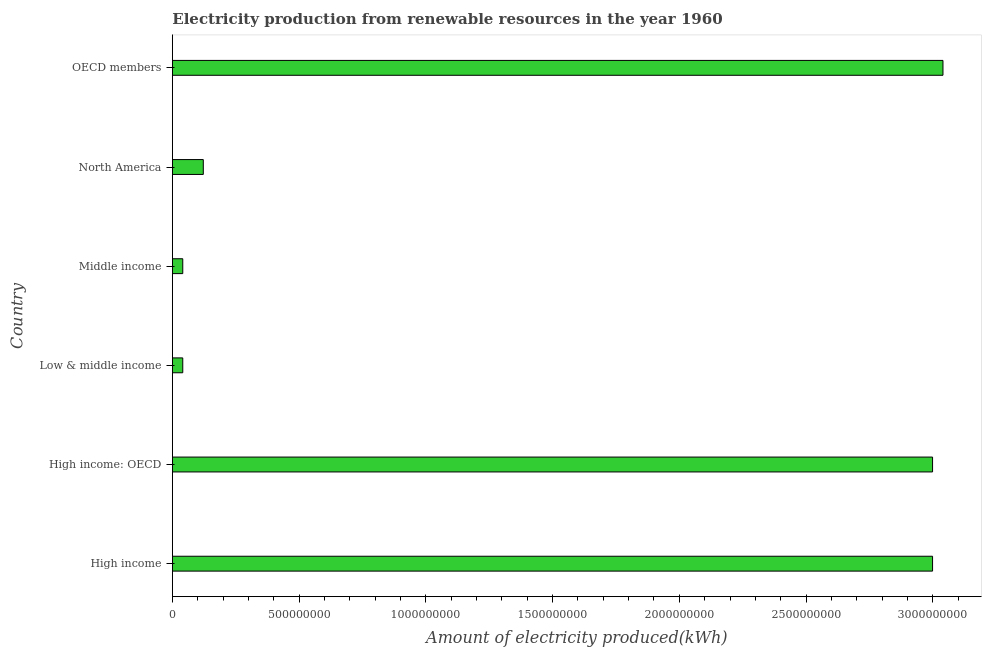What is the title of the graph?
Provide a short and direct response. Electricity production from renewable resources in the year 1960. What is the label or title of the X-axis?
Provide a short and direct response. Amount of electricity produced(kWh). What is the amount of electricity produced in Low & middle income?
Your answer should be compact. 4.10e+07. Across all countries, what is the maximum amount of electricity produced?
Ensure brevity in your answer.  3.04e+09. Across all countries, what is the minimum amount of electricity produced?
Ensure brevity in your answer.  4.10e+07. In which country was the amount of electricity produced minimum?
Provide a short and direct response. Low & middle income. What is the sum of the amount of electricity produced?
Provide a short and direct response. 9.24e+09. What is the difference between the amount of electricity produced in High income and Low & middle income?
Offer a very short reply. 2.96e+09. What is the average amount of electricity produced per country?
Your response must be concise. 1.54e+09. What is the median amount of electricity produced?
Ensure brevity in your answer.  1.56e+09. In how many countries, is the amount of electricity produced greater than 2700000000 kWh?
Keep it short and to the point. 3. What is the ratio of the amount of electricity produced in High income to that in High income: OECD?
Ensure brevity in your answer.  1. Is the amount of electricity produced in High income less than that in OECD members?
Make the answer very short. Yes. What is the difference between the highest and the second highest amount of electricity produced?
Offer a terse response. 4.10e+07. Is the sum of the amount of electricity produced in High income and North America greater than the maximum amount of electricity produced across all countries?
Provide a succinct answer. Yes. What is the difference between the highest and the lowest amount of electricity produced?
Ensure brevity in your answer.  3.00e+09. In how many countries, is the amount of electricity produced greater than the average amount of electricity produced taken over all countries?
Your answer should be compact. 3. Are all the bars in the graph horizontal?
Give a very brief answer. Yes. What is the difference between two consecutive major ticks on the X-axis?
Offer a very short reply. 5.00e+08. What is the Amount of electricity produced(kWh) in High income?
Provide a succinct answer. 3.00e+09. What is the Amount of electricity produced(kWh) in High income: OECD?
Ensure brevity in your answer.  3.00e+09. What is the Amount of electricity produced(kWh) of Low & middle income?
Provide a short and direct response. 4.10e+07. What is the Amount of electricity produced(kWh) in Middle income?
Ensure brevity in your answer.  4.10e+07. What is the Amount of electricity produced(kWh) of North America?
Ensure brevity in your answer.  1.22e+08. What is the Amount of electricity produced(kWh) of OECD members?
Your answer should be compact. 3.04e+09. What is the difference between the Amount of electricity produced(kWh) in High income and High income: OECD?
Offer a terse response. 0. What is the difference between the Amount of electricity produced(kWh) in High income and Low & middle income?
Your answer should be compact. 2.96e+09. What is the difference between the Amount of electricity produced(kWh) in High income and Middle income?
Give a very brief answer. 2.96e+09. What is the difference between the Amount of electricity produced(kWh) in High income and North America?
Your answer should be compact. 2.88e+09. What is the difference between the Amount of electricity produced(kWh) in High income and OECD members?
Your answer should be very brief. -4.10e+07. What is the difference between the Amount of electricity produced(kWh) in High income: OECD and Low & middle income?
Give a very brief answer. 2.96e+09. What is the difference between the Amount of electricity produced(kWh) in High income: OECD and Middle income?
Make the answer very short. 2.96e+09. What is the difference between the Amount of electricity produced(kWh) in High income: OECD and North America?
Give a very brief answer. 2.88e+09. What is the difference between the Amount of electricity produced(kWh) in High income: OECD and OECD members?
Make the answer very short. -4.10e+07. What is the difference between the Amount of electricity produced(kWh) in Low & middle income and Middle income?
Provide a short and direct response. 0. What is the difference between the Amount of electricity produced(kWh) in Low & middle income and North America?
Give a very brief answer. -8.10e+07. What is the difference between the Amount of electricity produced(kWh) in Low & middle income and OECD members?
Provide a short and direct response. -3.00e+09. What is the difference between the Amount of electricity produced(kWh) in Middle income and North America?
Your response must be concise. -8.10e+07. What is the difference between the Amount of electricity produced(kWh) in Middle income and OECD members?
Offer a terse response. -3.00e+09. What is the difference between the Amount of electricity produced(kWh) in North America and OECD members?
Keep it short and to the point. -2.92e+09. What is the ratio of the Amount of electricity produced(kWh) in High income to that in High income: OECD?
Offer a terse response. 1. What is the ratio of the Amount of electricity produced(kWh) in High income to that in Low & middle income?
Offer a very short reply. 73.15. What is the ratio of the Amount of electricity produced(kWh) in High income to that in Middle income?
Ensure brevity in your answer.  73.15. What is the ratio of the Amount of electricity produced(kWh) in High income to that in North America?
Offer a very short reply. 24.58. What is the ratio of the Amount of electricity produced(kWh) in High income: OECD to that in Low & middle income?
Provide a succinct answer. 73.15. What is the ratio of the Amount of electricity produced(kWh) in High income: OECD to that in Middle income?
Make the answer very short. 73.15. What is the ratio of the Amount of electricity produced(kWh) in High income: OECD to that in North America?
Provide a succinct answer. 24.58. What is the ratio of the Amount of electricity produced(kWh) in High income: OECD to that in OECD members?
Your response must be concise. 0.99. What is the ratio of the Amount of electricity produced(kWh) in Low & middle income to that in North America?
Provide a succinct answer. 0.34. What is the ratio of the Amount of electricity produced(kWh) in Low & middle income to that in OECD members?
Offer a very short reply. 0.01. What is the ratio of the Amount of electricity produced(kWh) in Middle income to that in North America?
Provide a short and direct response. 0.34. What is the ratio of the Amount of electricity produced(kWh) in Middle income to that in OECD members?
Provide a succinct answer. 0.01. What is the ratio of the Amount of electricity produced(kWh) in North America to that in OECD members?
Ensure brevity in your answer.  0.04. 